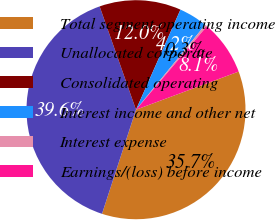Convert chart. <chart><loc_0><loc_0><loc_500><loc_500><pie_chart><fcel>Total segment operating income<fcel>Unallocated corporate<fcel>Consolidated operating<fcel>Interest income and other net<fcel>Interest expense<fcel>Earnings/(loss) before income<nl><fcel>35.68%<fcel>39.59%<fcel>12.04%<fcel>4.23%<fcel>0.32%<fcel>8.13%<nl></chart> 